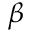Convert formula to latex. <formula><loc_0><loc_0><loc_500><loc_500>\beta</formula> 